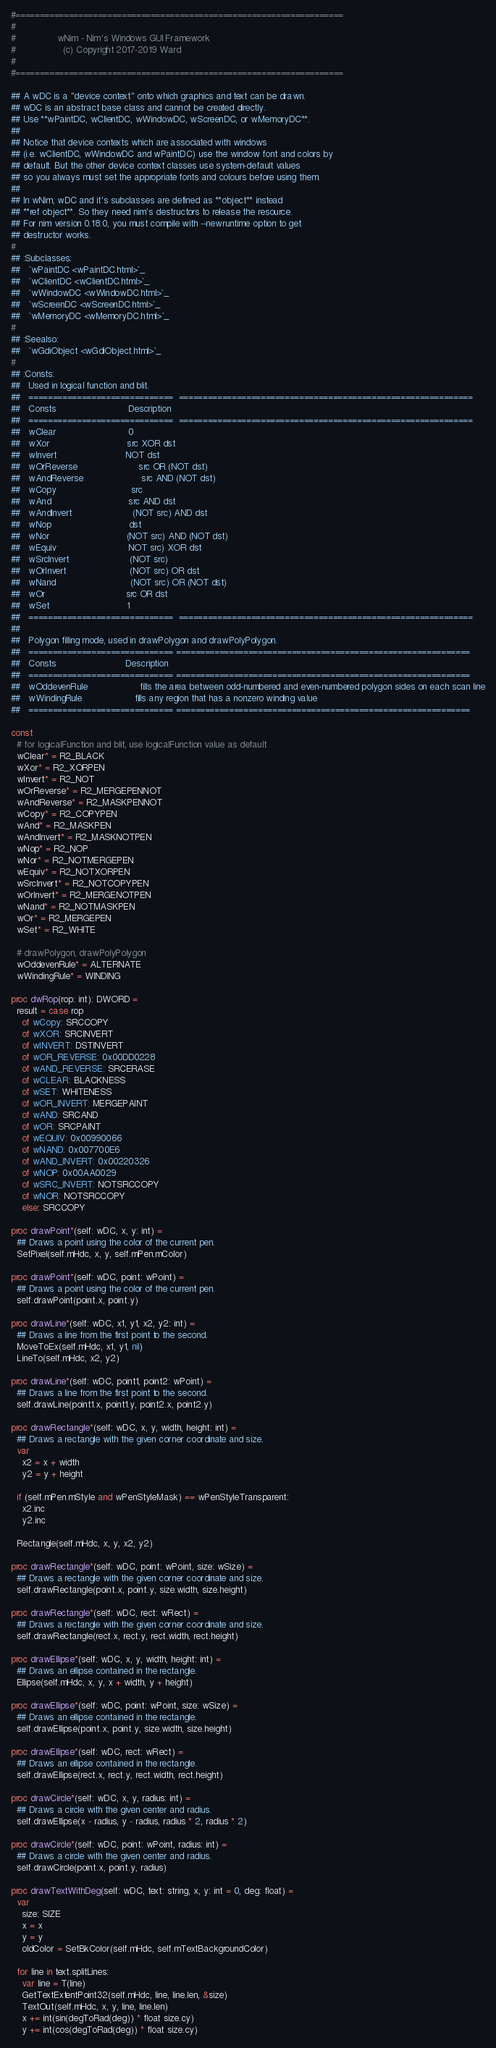<code> <loc_0><loc_0><loc_500><loc_500><_Nim_>#====================================================================
#
#               wNim - Nim's Windows GUI Framework
#                 (c) Copyright 2017-2019 Ward
#
#====================================================================

## A wDC is a "device context" onto which graphics and text can be drawn.
## wDC is an abstract base class and cannot be created directly.
## Use **wPaintDC, wClientDC, wWindowDC, wScreenDC, or wMemoryDC**.
##
## Notice that device contexts which are associated with windows
## (i.e. wClientDC, wWindowDC and wPaintDC) use the window font and colors by
## default. But the other device context classes use system-default values
## so you always must set the appropriate fonts and colours before using them.
##
## In wNim, wDC and it's subclasses are defined as **object** instead
## **ref object**. So they need nim's destructors to release the resource.
## For nim version 0.18.0, you must compile with --newruntime option to get
## destructor works.
#
## :Subclasses:
##   `wPaintDC <wPaintDC.html>`_
##   `wClientDC <wClientDC.html>`_
##   `wWindowDC <wWindowDC.html>`_
##   `wScreenDC <wScreenDC.html>`_
##   `wMemoryDC <wMemoryDC.html>`_
#
## :Seealso:
##   `wGdiObject <wGdiObject.html>`_
#
## :Consts:
##   Used in logical function and blit.
##   ==============================  =============================================================
##   Consts                          Description
##   ==============================  =============================================================
##   wClear                          0
##   wXor                            src XOR dst
##   wInvert                         NOT dst
##   wOrReverse                      src OR (NOT dst)
##   wAndReverse                     src AND (NOT dst)
##   wCopy                           src
##   wAnd                            src AND dst
##   wAndInvert                      (NOT src) AND dst
##   wNop                            dst
##   wNor                            (NOT src) AND (NOT dst)
##   wEquiv                          NOT src) XOR dst
##   wSrcInvert                      (NOT src)
##   wOrInvert                       (NOT src) OR dst
##   wNand                           (NOT src) OR (NOT dst)
##   wOr                             src OR dst
##   wSet                            1
##   ==============================  =============================================================
##
##   Polygon filling mode, used in drawPolygon and drawPolyPolygon.
##   ============================== =============================================================
##   Consts                         Description
##   ============================== =============================================================
##   wOddevenRule                   fills the area between odd-numbered and even-numbered polygon sides on each scan line
##   wWindingRule                   fills any region that has a nonzero winding value
##   ============================== =============================================================

const
  # for logicalFunction and blit, use logicalFunction value as default
  wClear* = R2_BLACK
  wXor* = R2_XORPEN
  wInvert* = R2_NOT
  wOrReverse* = R2_MERGEPENNOT
  wAndReverse* = R2_MASKPENNOT
  wCopy* = R2_COPYPEN
  wAnd* = R2_MASKPEN
  wAndInvert* = R2_MASKNOTPEN
  wNop* = R2_NOP
  wNor* = R2_NOTMERGEPEN
  wEquiv* = R2_NOTXORPEN
  wSrcInvert* = R2_NOTCOPYPEN
  wOrInvert* = R2_MERGENOTPEN
  wNand* = R2_NOTMASKPEN
  wOr* = R2_MERGEPEN
  wSet* = R2_WHITE

  # drawPolygon, drawPolyPolygon
  wOddevenRule* = ALTERNATE
  wWindingRule* = WINDING

proc dwRop(rop: int): DWORD =
  result = case rop
    of wCopy: SRCCOPY
    of wXOR: SRCINVERT
    of wINVERT: DSTINVERT
    of wOR_REVERSE: 0x00DD0228
    of wAND_REVERSE: SRCERASE
    of wCLEAR: BLACKNESS
    of wSET: WHITENESS
    of wOR_INVERT: MERGEPAINT
    of wAND: SRCAND
    of wOR: SRCPAINT
    of wEQUIV: 0x00990066
    of wNAND: 0x007700E6
    of wAND_INVERT: 0x00220326
    of wNOP: 0x00AA0029
    of wSRC_INVERT: NOTSRCCOPY
    of wNOR: NOTSRCCOPY
    else: SRCCOPY

proc drawPoint*(self: wDC, x, y: int) =
  ## Draws a point using the color of the current pen.
  SetPixel(self.mHdc, x, y, self.mPen.mColor)

proc drawPoint*(self: wDC, point: wPoint) =
  ## Draws a point using the color of the current pen.
  self.drawPoint(point.x, point.y)

proc drawLine*(self: wDC, x1, y1, x2, y2: int) =
  ## Draws a line from the first point to the second.
  MoveToEx(self.mHdc, x1, y1, nil)
  LineTo(self.mHdc, x2, y2)

proc drawLine*(self: wDC, point1, point2: wPoint) =
  ## Draws a line from the first point to the second.
  self.drawLine(point1.x, point1.y, point2.x, point2.y)

proc drawRectangle*(self: wDC, x, y, width, height: int) =
  ## Draws a rectangle with the given corner coordinate and size.
  var
    x2 = x + width
    y2 = y + height

  if (self.mPen.mStyle and wPenStyleMask) == wPenStyleTransparent:
    x2.inc
    y2.inc

  Rectangle(self.mHdc, x, y, x2, y2)

proc drawRectangle*(self: wDC, point: wPoint, size: wSize) =
  ## Draws a rectangle with the given corner coordinate and size.
  self.drawRectangle(point.x, point.y, size.width, size.height)

proc drawRectangle*(self: wDC, rect: wRect) =
  ## Draws a rectangle with the given corner coordinate and size.
  self.drawRectangle(rect.x, rect.y, rect.width, rect.height)

proc drawEllipse*(self: wDC, x, y, width, height: int) =
  ## Draws an ellipse contained in the rectangle.
  Ellipse(self.mHdc, x, y, x + width, y + height)

proc drawEllipse*(self: wDC, point: wPoint, size: wSize) =
  ## Draws an ellipse contained in the rectangle.
  self.drawEllipse(point.x, point.y, size.width, size.height)

proc drawEllipse*(self: wDC, rect: wRect) =
  ## Draws an ellipse contained in the rectangle.
  self.drawEllipse(rect.x, rect.y, rect.width, rect.height)

proc drawCircle*(self: wDC, x, y, radius: int) =
  ## Draws a circle with the given center and radius.
  self.drawEllipse(x - radius, y - radius, radius * 2, radius * 2)

proc drawCircle*(self: wDC, point: wPoint, radius: int) =
  ## Draws a circle with the given center and radius.
  self.drawCircle(point.x, point.y, radius)

proc drawTextWithDeg(self: wDC, text: string, x, y: int = 0, deg: float) =
  var
    size: SIZE
    x = x
    y = y
    oldColor = SetBkColor(self.mHdc, self.mTextBackgroundColor)

  for line in text.splitLines:
    var line = T(line)
    GetTextExtentPoint32(self.mHdc, line, line.len, &size)
    TextOut(self.mHdc, x, y, line, line.len)
    x += int(sin(degToRad(deg)) * float size.cy)
    y += int(cos(degToRad(deg)) * float size.cy)</code> 